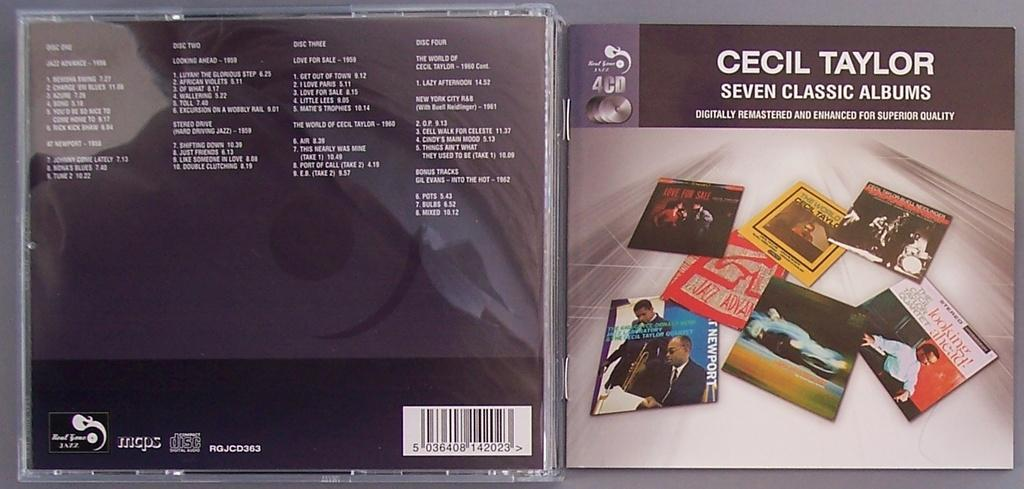<image>
Share a concise interpretation of the image provided. A music album from Cecil Taylor contains a collection of songs. 